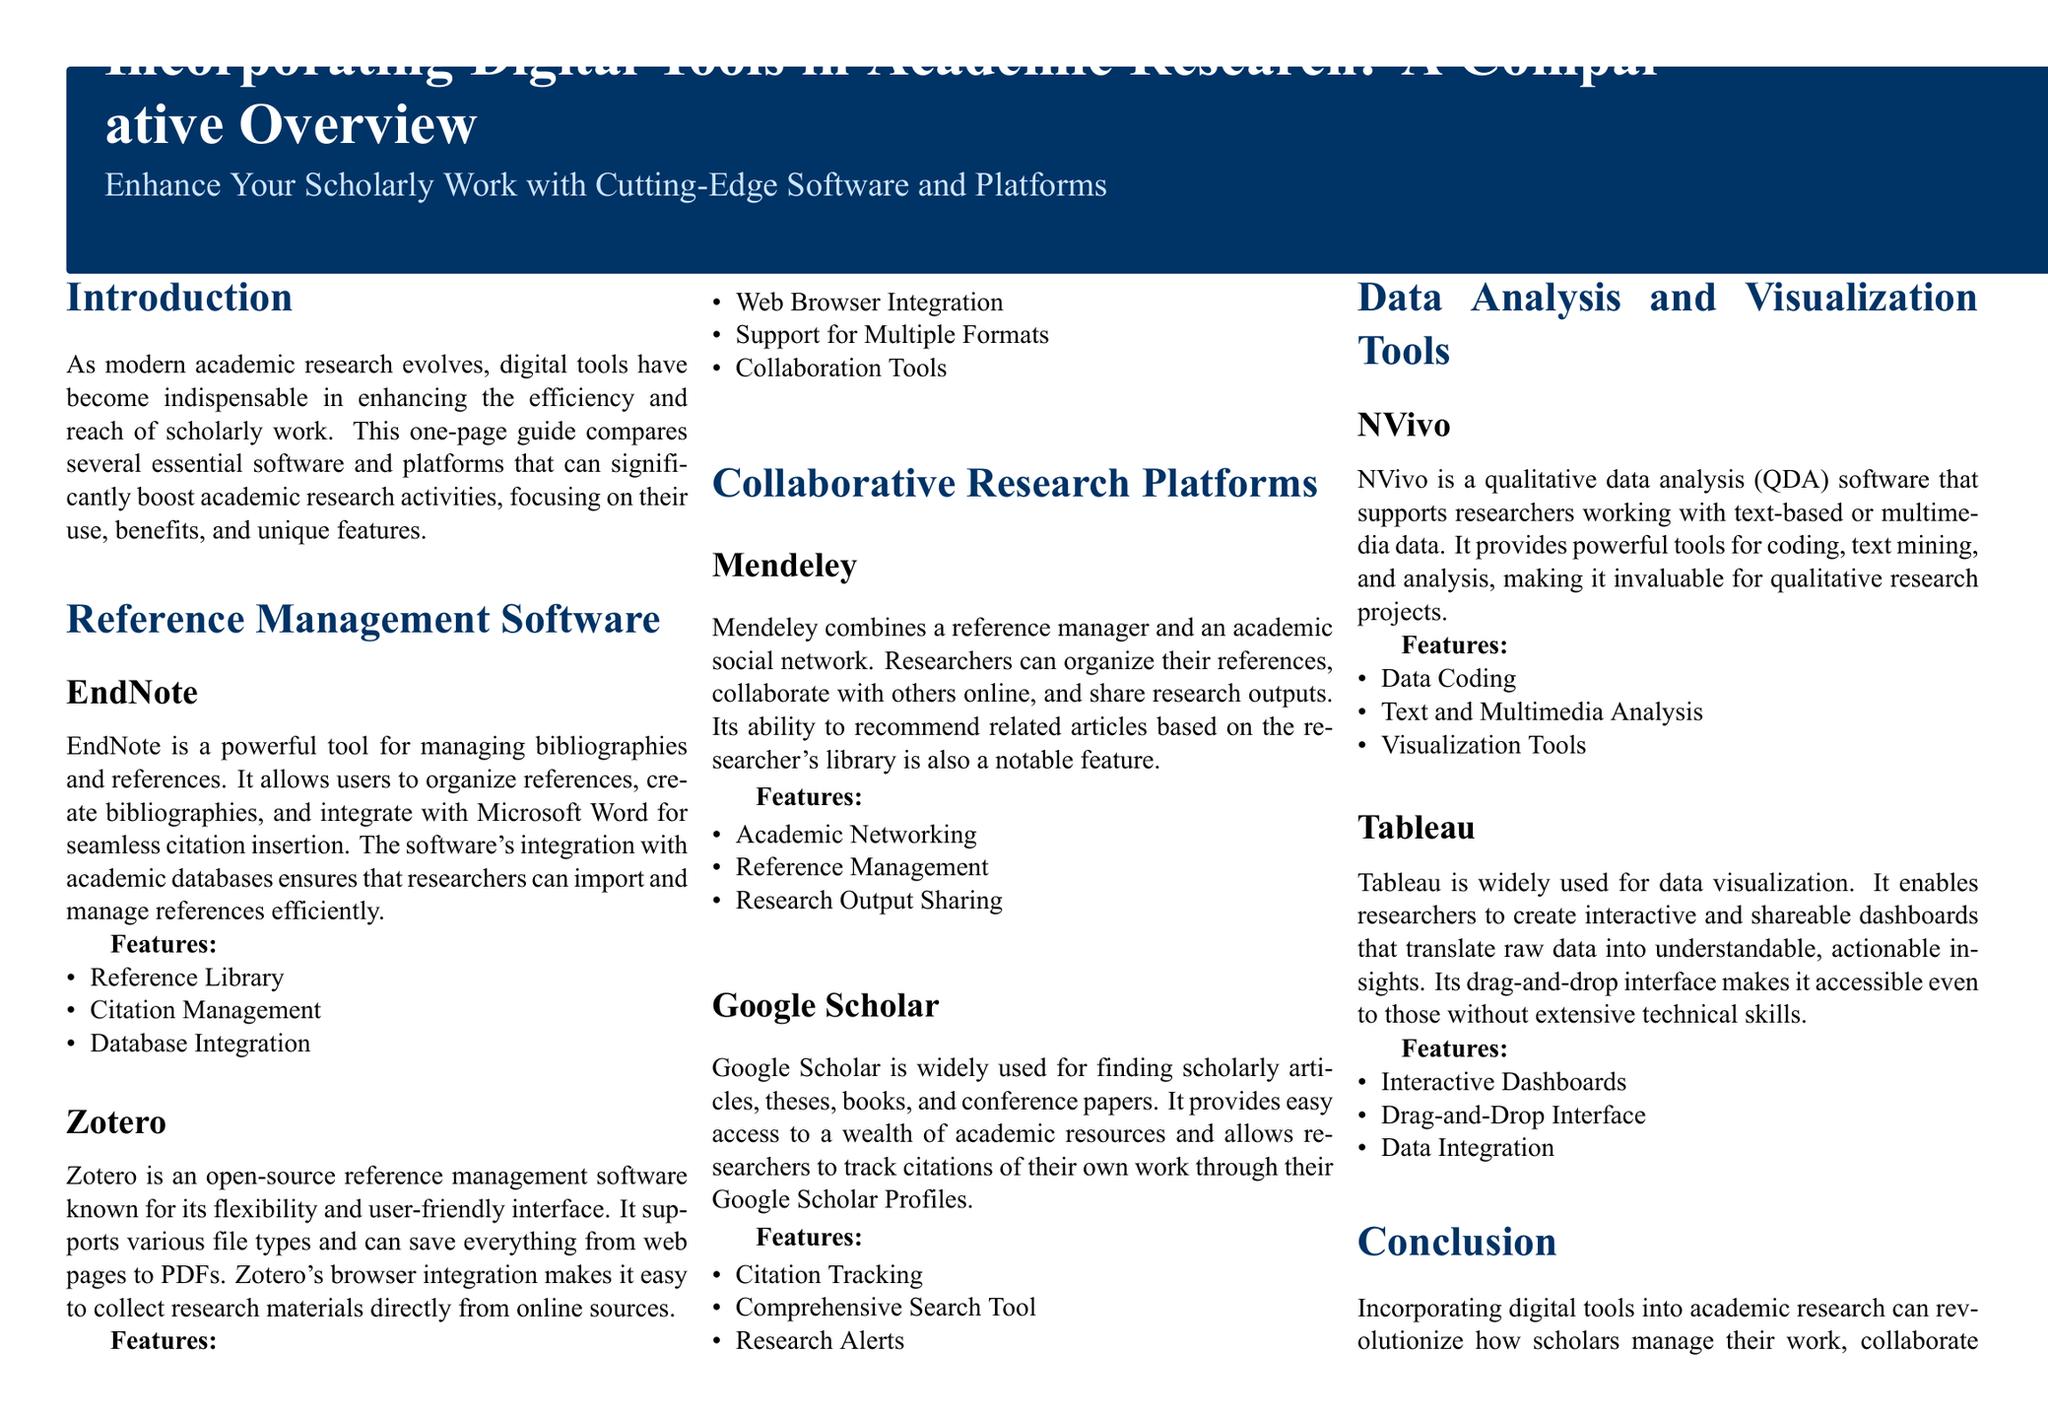What is the title of the document? The title is prominently displayed in a larger font at the top of the document.
Answer: Incorporating Digital Tools in Academic Research: A Comparative Overview How many reference management software are mentioned? The section lists how many software programs are discussed under reference management.
Answer: Two What platform combines reference management with an academic social network? This information can be found in the section about collaborative research platforms where Mendeley is mentioned.
Answer: Mendeley Which software is known for its data visualization capabilities? This can be answered by looking at the section discussing data analysis and visualization tools.
Answer: Tableau What feature does Zotero provide that is highlighted in the document? The document specifies unique features of Zotero under its description.
Answer: Browser Integration What type of data analysis does NVivo specialize in? NVivo's focus is described within its section regarding data analysis tools.
Answer: Qualitative data analysis Which research platform allows citation tracking? This information is explicitly stated in the features of Google Scholar.
Answer: Google Scholar What is the color of the main header background? The background color is defined in the visual elements of the magazine layout.
Answer: RGB(0,51,102) How does incorporating digital tools benefit academic research? The conclusion summarizes the advantages of utilizing such tools in scholarly work.
Answer: Enhances quality, efficiency, and impact 